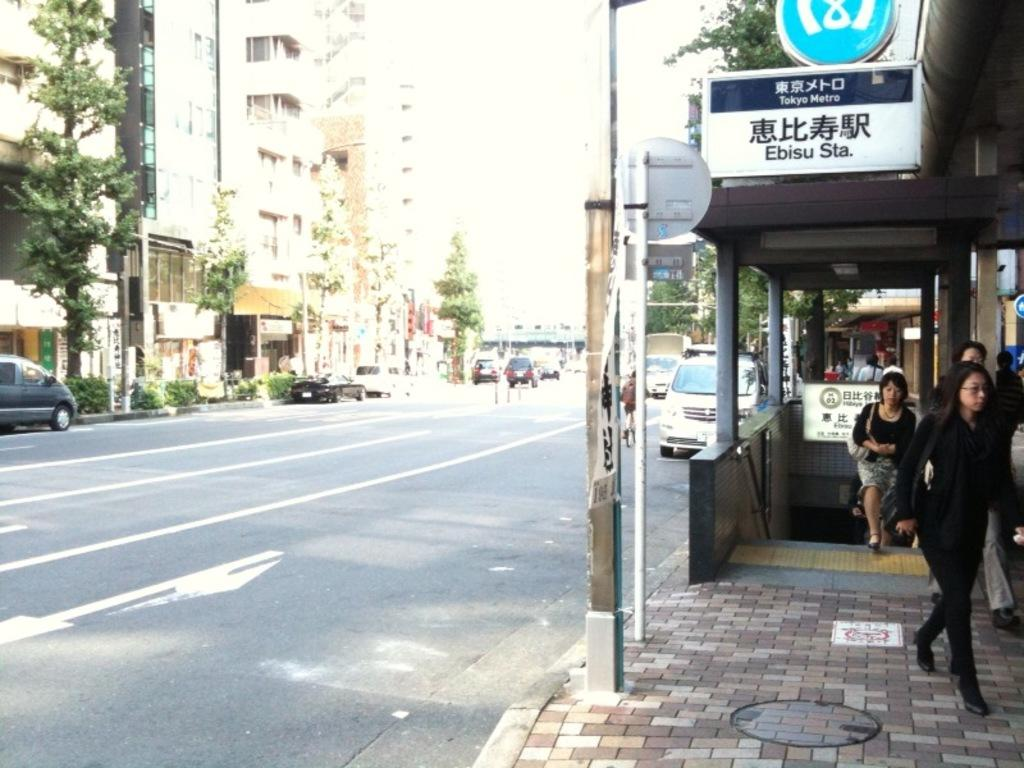Provide a one-sentence caption for the provided image. A group of people walk up from the Ebisu Subway Station in Japan. 